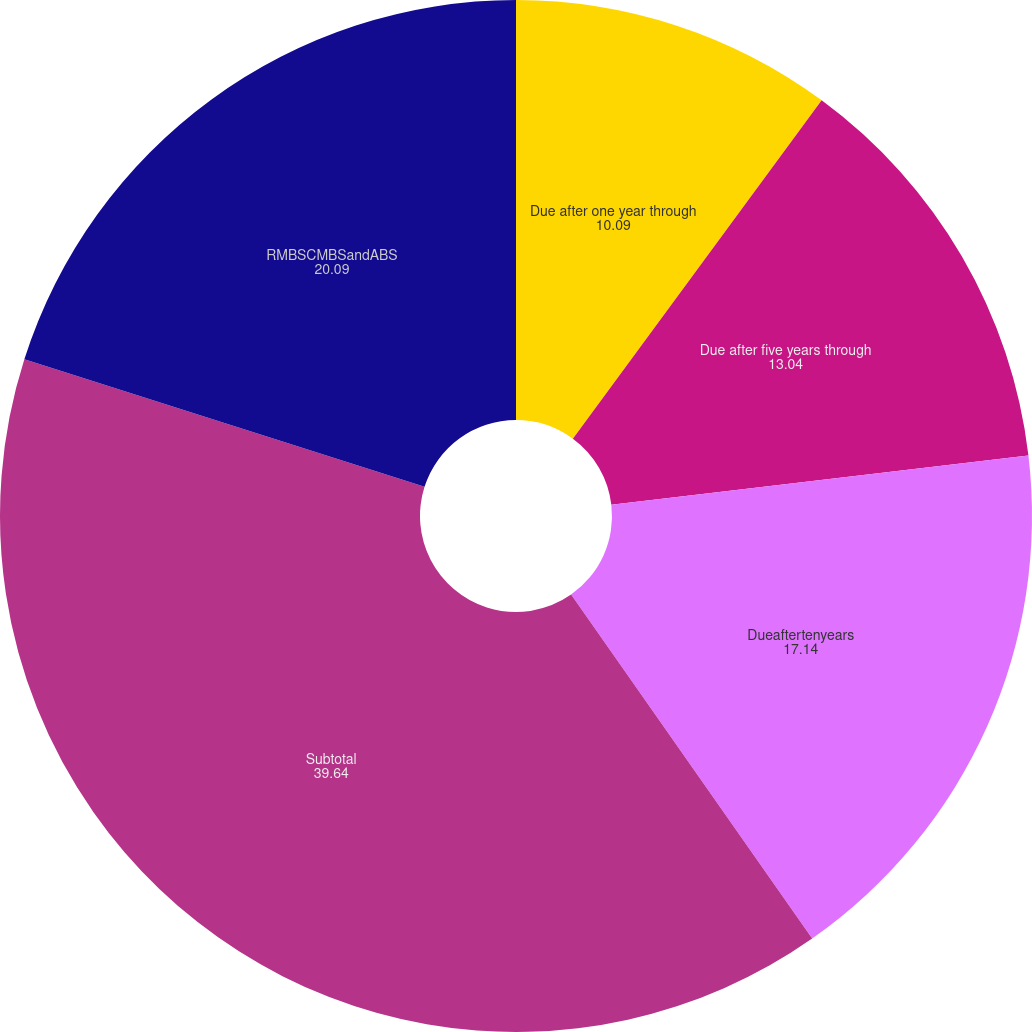Convert chart. <chart><loc_0><loc_0><loc_500><loc_500><pie_chart><fcel>Due after one year through<fcel>Due after five years through<fcel>Dueaftertenyears<fcel>Subtotal<fcel>RMBSCMBSandABS<nl><fcel>10.09%<fcel>13.04%<fcel>17.14%<fcel>39.64%<fcel>20.09%<nl></chart> 